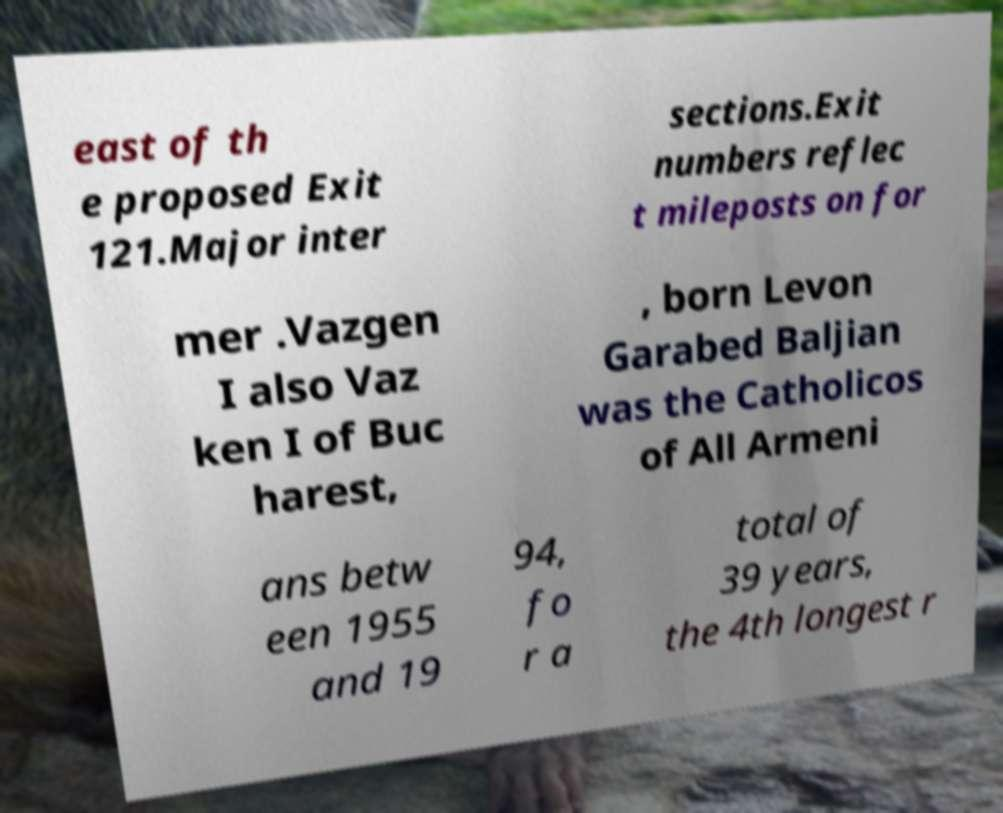Could you assist in decoding the text presented in this image and type it out clearly? east of th e proposed Exit 121.Major inter sections.Exit numbers reflec t mileposts on for mer .Vazgen I also Vaz ken I of Buc harest, , born Levon Garabed Baljian was the Catholicos of All Armeni ans betw een 1955 and 19 94, fo r a total of 39 years, the 4th longest r 